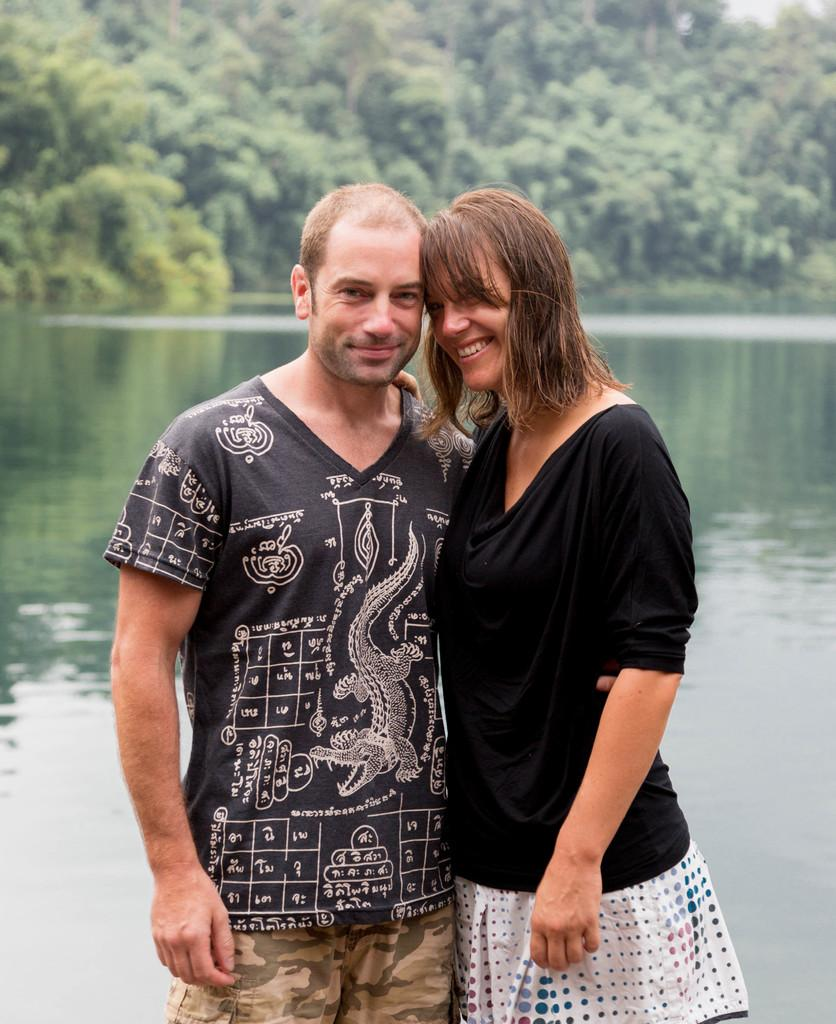How many people are present in the image? There are two people, a man and a woman, present in the image. What can be seen in the background of the image? There is water visible in the background of the image. What type of vegetation is present in the image? There are trees in the image. What type of game are the boys playing in the image? There are no boys present in the image, and therefore no game can be observed. 